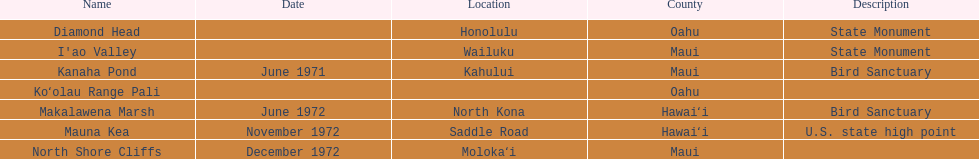What is the name of the only landmark that is also a u.s. state high point? Mauna Kea. 